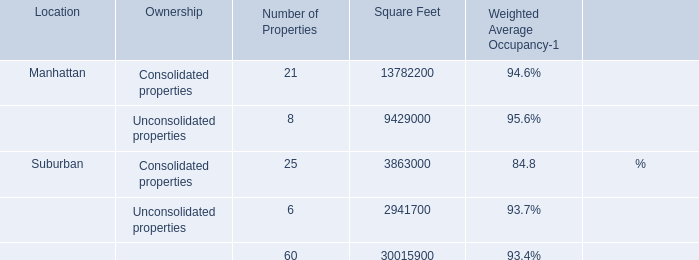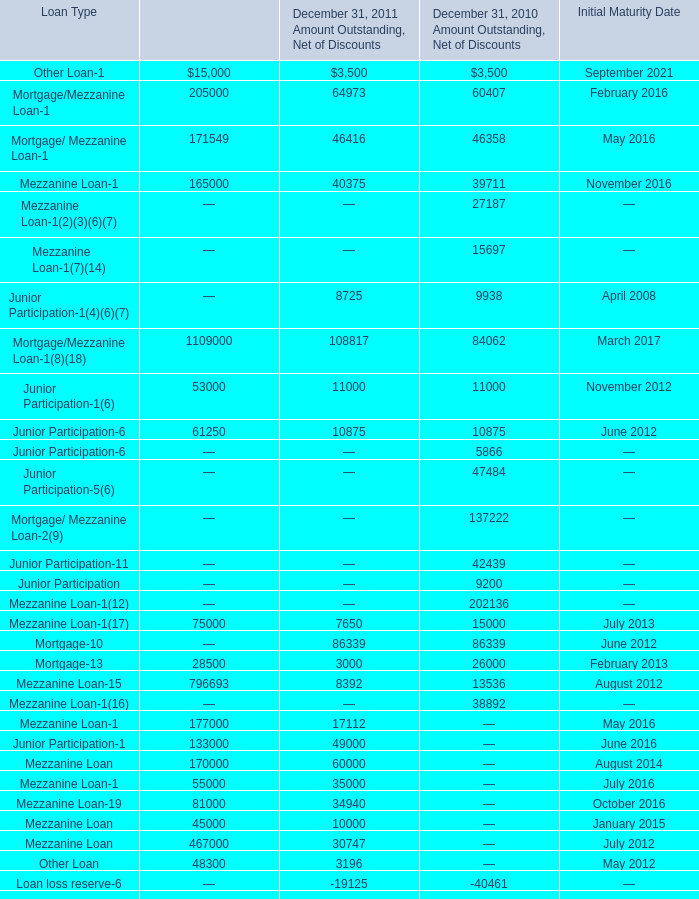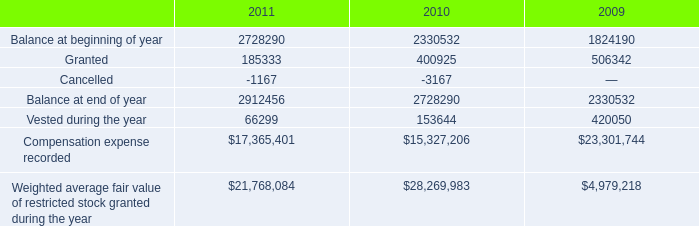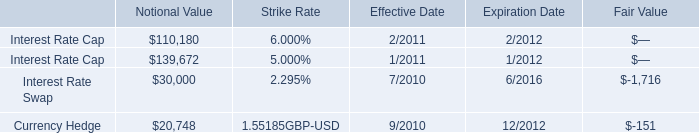What's the sum of Suburban of Square Feet, Interest Rate Cap of Notional Value, and Weighted average fair value of restricted stock granted during the year of 2009 ? 
Computations: ((3863000.0 + 139672.0) + 4979218.0)
Answer: 8981890.0. 